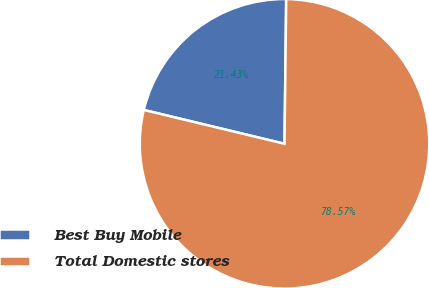<chart> <loc_0><loc_0><loc_500><loc_500><pie_chart><fcel>Best Buy Mobile<fcel>Total Domestic stores<nl><fcel>21.43%<fcel>78.57%<nl></chart> 